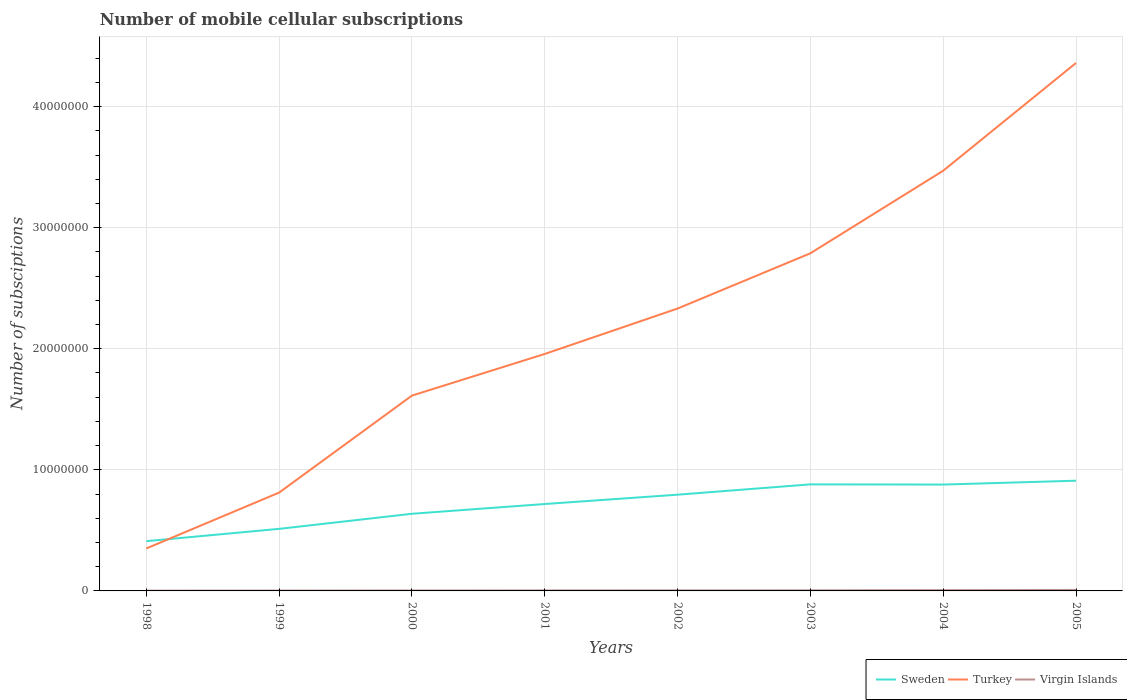Is the number of lines equal to the number of legend labels?
Keep it short and to the point. Yes. Across all years, what is the maximum number of mobile cellular subscriptions in Virgin Islands?
Your response must be concise. 2.50e+04. In which year was the number of mobile cellular subscriptions in Sweden maximum?
Your response must be concise. 1998. What is the total number of mobile cellular subscriptions in Sweden in the graph?
Ensure brevity in your answer.  -1.25e+06. What is the difference between the highest and the second highest number of mobile cellular subscriptions in Sweden?
Ensure brevity in your answer.  5.00e+06. What is the difference between the highest and the lowest number of mobile cellular subscriptions in Sweden?
Offer a very short reply. 4. How many lines are there?
Provide a succinct answer. 3. How many years are there in the graph?
Give a very brief answer. 8. Are the values on the major ticks of Y-axis written in scientific E-notation?
Ensure brevity in your answer.  No. How many legend labels are there?
Make the answer very short. 3. How are the legend labels stacked?
Provide a succinct answer. Horizontal. What is the title of the graph?
Provide a succinct answer. Number of mobile cellular subscriptions. Does "Chile" appear as one of the legend labels in the graph?
Provide a short and direct response. No. What is the label or title of the Y-axis?
Your answer should be very brief. Number of subsciptions. What is the Number of subsciptions of Sweden in 1998?
Make the answer very short. 4.11e+06. What is the Number of subsciptions in Turkey in 1998?
Offer a very short reply. 3.51e+06. What is the Number of subsciptions in Virgin Islands in 1998?
Offer a terse response. 2.50e+04. What is the Number of subsciptions in Sweden in 1999?
Your answer should be very brief. 5.13e+06. What is the Number of subsciptions of Turkey in 1999?
Keep it short and to the point. 8.12e+06. What is the Number of subsciptions in Sweden in 2000?
Your response must be concise. 6.37e+06. What is the Number of subsciptions of Turkey in 2000?
Provide a succinct answer. 1.61e+07. What is the Number of subsciptions of Virgin Islands in 2000?
Keep it short and to the point. 3.50e+04. What is the Number of subsciptions of Sweden in 2001?
Give a very brief answer. 7.18e+06. What is the Number of subsciptions of Turkey in 2001?
Your response must be concise. 1.96e+07. What is the Number of subsciptions of Virgin Islands in 2001?
Provide a succinct answer. 4.10e+04. What is the Number of subsciptions of Sweden in 2002?
Give a very brief answer. 7.95e+06. What is the Number of subsciptions in Turkey in 2002?
Ensure brevity in your answer.  2.33e+07. What is the Number of subsciptions of Virgin Islands in 2002?
Ensure brevity in your answer.  4.52e+04. What is the Number of subsciptions in Sweden in 2003?
Ensure brevity in your answer.  8.80e+06. What is the Number of subsciptions in Turkey in 2003?
Your answer should be very brief. 2.79e+07. What is the Number of subsciptions of Virgin Islands in 2003?
Your answer should be very brief. 4.93e+04. What is the Number of subsciptions of Sweden in 2004?
Offer a very short reply. 8.78e+06. What is the Number of subsciptions of Turkey in 2004?
Your answer should be compact. 3.47e+07. What is the Number of subsciptions in Virgin Islands in 2004?
Your answer should be compact. 6.42e+04. What is the Number of subsciptions in Sweden in 2005?
Make the answer very short. 9.10e+06. What is the Number of subsciptions in Turkey in 2005?
Offer a terse response. 4.36e+07. What is the Number of subsciptions in Virgin Islands in 2005?
Your answer should be very brief. 8.03e+04. Across all years, what is the maximum Number of subsciptions of Sweden?
Make the answer very short. 9.10e+06. Across all years, what is the maximum Number of subsciptions of Turkey?
Your response must be concise. 4.36e+07. Across all years, what is the maximum Number of subsciptions of Virgin Islands?
Offer a very short reply. 8.03e+04. Across all years, what is the minimum Number of subsciptions in Sweden?
Your answer should be very brief. 4.11e+06. Across all years, what is the minimum Number of subsciptions in Turkey?
Your answer should be very brief. 3.51e+06. Across all years, what is the minimum Number of subsciptions in Virgin Islands?
Offer a very short reply. 2.50e+04. What is the total Number of subsciptions of Sweden in the graph?
Offer a terse response. 5.74e+07. What is the total Number of subsciptions of Turkey in the graph?
Ensure brevity in your answer.  1.77e+08. What is the total Number of subsciptions of Virgin Islands in the graph?
Give a very brief answer. 3.70e+05. What is the difference between the Number of subsciptions in Sweden in 1998 and that in 1999?
Your answer should be compact. -1.02e+06. What is the difference between the Number of subsciptions in Turkey in 1998 and that in 1999?
Provide a succinct answer. -4.62e+06. What is the difference between the Number of subsciptions in Virgin Islands in 1998 and that in 1999?
Ensure brevity in your answer.  -5000. What is the difference between the Number of subsciptions in Sweden in 1998 and that in 2000?
Provide a short and direct response. -2.26e+06. What is the difference between the Number of subsciptions of Turkey in 1998 and that in 2000?
Offer a very short reply. -1.26e+07. What is the difference between the Number of subsciptions in Sweden in 1998 and that in 2001?
Offer a terse response. -3.07e+06. What is the difference between the Number of subsciptions of Turkey in 1998 and that in 2001?
Give a very brief answer. -1.61e+07. What is the difference between the Number of subsciptions of Virgin Islands in 1998 and that in 2001?
Ensure brevity in your answer.  -1.60e+04. What is the difference between the Number of subsciptions in Sweden in 1998 and that in 2002?
Your answer should be very brief. -3.84e+06. What is the difference between the Number of subsciptions of Turkey in 1998 and that in 2002?
Offer a very short reply. -1.98e+07. What is the difference between the Number of subsciptions of Virgin Islands in 1998 and that in 2002?
Provide a succinct answer. -2.02e+04. What is the difference between the Number of subsciptions in Sweden in 1998 and that in 2003?
Ensure brevity in your answer.  -4.69e+06. What is the difference between the Number of subsciptions of Turkey in 1998 and that in 2003?
Offer a terse response. -2.44e+07. What is the difference between the Number of subsciptions of Virgin Islands in 1998 and that in 2003?
Make the answer very short. -2.43e+04. What is the difference between the Number of subsciptions of Sweden in 1998 and that in 2004?
Keep it short and to the point. -4.68e+06. What is the difference between the Number of subsciptions of Turkey in 1998 and that in 2004?
Ensure brevity in your answer.  -3.12e+07. What is the difference between the Number of subsciptions of Virgin Islands in 1998 and that in 2004?
Provide a short and direct response. -3.92e+04. What is the difference between the Number of subsciptions in Sweden in 1998 and that in 2005?
Offer a terse response. -5.00e+06. What is the difference between the Number of subsciptions of Turkey in 1998 and that in 2005?
Give a very brief answer. -4.01e+07. What is the difference between the Number of subsciptions in Virgin Islands in 1998 and that in 2005?
Offer a very short reply. -5.53e+04. What is the difference between the Number of subsciptions of Sweden in 1999 and that in 2000?
Provide a short and direct response. -1.25e+06. What is the difference between the Number of subsciptions of Turkey in 1999 and that in 2000?
Keep it short and to the point. -8.01e+06. What is the difference between the Number of subsciptions in Virgin Islands in 1999 and that in 2000?
Provide a succinct answer. -5000. What is the difference between the Number of subsciptions in Sweden in 1999 and that in 2001?
Your answer should be compact. -2.05e+06. What is the difference between the Number of subsciptions of Turkey in 1999 and that in 2001?
Provide a short and direct response. -1.15e+07. What is the difference between the Number of subsciptions in Virgin Islands in 1999 and that in 2001?
Offer a very short reply. -1.10e+04. What is the difference between the Number of subsciptions of Sweden in 1999 and that in 2002?
Your response must be concise. -2.82e+06. What is the difference between the Number of subsciptions of Turkey in 1999 and that in 2002?
Offer a very short reply. -1.52e+07. What is the difference between the Number of subsciptions of Virgin Islands in 1999 and that in 2002?
Offer a very short reply. -1.52e+04. What is the difference between the Number of subsciptions in Sweden in 1999 and that in 2003?
Your answer should be very brief. -3.68e+06. What is the difference between the Number of subsciptions of Turkey in 1999 and that in 2003?
Ensure brevity in your answer.  -1.98e+07. What is the difference between the Number of subsciptions of Virgin Islands in 1999 and that in 2003?
Make the answer very short. -1.93e+04. What is the difference between the Number of subsciptions in Sweden in 1999 and that in 2004?
Ensure brevity in your answer.  -3.66e+06. What is the difference between the Number of subsciptions in Turkey in 1999 and that in 2004?
Ensure brevity in your answer.  -2.66e+07. What is the difference between the Number of subsciptions of Virgin Islands in 1999 and that in 2004?
Your response must be concise. -3.42e+04. What is the difference between the Number of subsciptions of Sweden in 1999 and that in 2005?
Make the answer very short. -3.98e+06. What is the difference between the Number of subsciptions in Turkey in 1999 and that in 2005?
Give a very brief answer. -3.55e+07. What is the difference between the Number of subsciptions in Virgin Islands in 1999 and that in 2005?
Ensure brevity in your answer.  -5.03e+04. What is the difference between the Number of subsciptions in Sweden in 2000 and that in 2001?
Keep it short and to the point. -8.06e+05. What is the difference between the Number of subsciptions of Turkey in 2000 and that in 2001?
Offer a very short reply. -3.44e+06. What is the difference between the Number of subsciptions in Virgin Islands in 2000 and that in 2001?
Offer a terse response. -6000. What is the difference between the Number of subsciptions of Sweden in 2000 and that in 2002?
Provide a short and direct response. -1.58e+06. What is the difference between the Number of subsciptions in Turkey in 2000 and that in 2002?
Give a very brief answer. -7.19e+06. What is the difference between the Number of subsciptions of Virgin Islands in 2000 and that in 2002?
Provide a short and direct response. -1.02e+04. What is the difference between the Number of subsciptions in Sweden in 2000 and that in 2003?
Give a very brief answer. -2.43e+06. What is the difference between the Number of subsciptions of Turkey in 2000 and that in 2003?
Your answer should be very brief. -1.18e+07. What is the difference between the Number of subsciptions in Virgin Islands in 2000 and that in 2003?
Offer a very short reply. -1.43e+04. What is the difference between the Number of subsciptions in Sweden in 2000 and that in 2004?
Give a very brief answer. -2.41e+06. What is the difference between the Number of subsciptions of Turkey in 2000 and that in 2004?
Offer a terse response. -1.86e+07. What is the difference between the Number of subsciptions of Virgin Islands in 2000 and that in 2004?
Offer a very short reply. -2.92e+04. What is the difference between the Number of subsciptions of Sweden in 2000 and that in 2005?
Ensure brevity in your answer.  -2.73e+06. What is the difference between the Number of subsciptions of Turkey in 2000 and that in 2005?
Your answer should be compact. -2.75e+07. What is the difference between the Number of subsciptions of Virgin Islands in 2000 and that in 2005?
Give a very brief answer. -4.53e+04. What is the difference between the Number of subsciptions in Sweden in 2001 and that in 2002?
Make the answer very short. -7.71e+05. What is the difference between the Number of subsciptions in Turkey in 2001 and that in 2002?
Your response must be concise. -3.75e+06. What is the difference between the Number of subsciptions in Virgin Islands in 2001 and that in 2002?
Keep it short and to the point. -4150. What is the difference between the Number of subsciptions in Sweden in 2001 and that in 2003?
Ensure brevity in your answer.  -1.62e+06. What is the difference between the Number of subsciptions in Turkey in 2001 and that in 2003?
Make the answer very short. -8.31e+06. What is the difference between the Number of subsciptions in Virgin Islands in 2001 and that in 2003?
Provide a succinct answer. -8300. What is the difference between the Number of subsciptions of Sweden in 2001 and that in 2004?
Provide a short and direct response. -1.61e+06. What is the difference between the Number of subsciptions in Turkey in 2001 and that in 2004?
Your response must be concise. -1.51e+07. What is the difference between the Number of subsciptions in Virgin Islands in 2001 and that in 2004?
Make the answer very short. -2.32e+04. What is the difference between the Number of subsciptions in Sweden in 2001 and that in 2005?
Make the answer very short. -1.93e+06. What is the difference between the Number of subsciptions in Turkey in 2001 and that in 2005?
Provide a short and direct response. -2.40e+07. What is the difference between the Number of subsciptions of Virgin Islands in 2001 and that in 2005?
Keep it short and to the point. -3.93e+04. What is the difference between the Number of subsciptions of Sweden in 2002 and that in 2003?
Offer a terse response. -8.52e+05. What is the difference between the Number of subsciptions in Turkey in 2002 and that in 2003?
Provide a short and direct response. -4.56e+06. What is the difference between the Number of subsciptions of Virgin Islands in 2002 and that in 2003?
Provide a succinct answer. -4150. What is the difference between the Number of subsciptions in Sweden in 2002 and that in 2004?
Your answer should be very brief. -8.36e+05. What is the difference between the Number of subsciptions in Turkey in 2002 and that in 2004?
Your answer should be compact. -1.14e+07. What is the difference between the Number of subsciptions of Virgin Islands in 2002 and that in 2004?
Provide a short and direct response. -1.90e+04. What is the difference between the Number of subsciptions in Sweden in 2002 and that in 2005?
Your answer should be very brief. -1.16e+06. What is the difference between the Number of subsciptions in Turkey in 2002 and that in 2005?
Offer a very short reply. -2.03e+07. What is the difference between the Number of subsciptions of Virgin Islands in 2002 and that in 2005?
Keep it short and to the point. -3.52e+04. What is the difference between the Number of subsciptions of Sweden in 2003 and that in 2004?
Provide a succinct answer. 1.60e+04. What is the difference between the Number of subsciptions of Turkey in 2003 and that in 2004?
Offer a terse response. -6.82e+06. What is the difference between the Number of subsciptions of Virgin Islands in 2003 and that in 2004?
Ensure brevity in your answer.  -1.49e+04. What is the difference between the Number of subsciptions of Sweden in 2003 and that in 2005?
Provide a succinct answer. -3.03e+05. What is the difference between the Number of subsciptions of Turkey in 2003 and that in 2005?
Provide a succinct answer. -1.57e+07. What is the difference between the Number of subsciptions of Virgin Islands in 2003 and that in 2005?
Provide a short and direct response. -3.10e+04. What is the difference between the Number of subsciptions in Sweden in 2004 and that in 2005?
Your answer should be very brief. -3.19e+05. What is the difference between the Number of subsciptions in Turkey in 2004 and that in 2005?
Your answer should be compact. -8.90e+06. What is the difference between the Number of subsciptions in Virgin Islands in 2004 and that in 2005?
Provide a succinct answer. -1.61e+04. What is the difference between the Number of subsciptions in Sweden in 1998 and the Number of subsciptions in Turkey in 1999?
Offer a very short reply. -4.01e+06. What is the difference between the Number of subsciptions in Sweden in 1998 and the Number of subsciptions in Virgin Islands in 1999?
Ensure brevity in your answer.  4.08e+06. What is the difference between the Number of subsciptions of Turkey in 1998 and the Number of subsciptions of Virgin Islands in 1999?
Give a very brief answer. 3.48e+06. What is the difference between the Number of subsciptions of Sweden in 1998 and the Number of subsciptions of Turkey in 2000?
Provide a succinct answer. -1.20e+07. What is the difference between the Number of subsciptions in Sweden in 1998 and the Number of subsciptions in Virgin Islands in 2000?
Your response must be concise. 4.07e+06. What is the difference between the Number of subsciptions of Turkey in 1998 and the Number of subsciptions of Virgin Islands in 2000?
Provide a succinct answer. 3.47e+06. What is the difference between the Number of subsciptions of Sweden in 1998 and the Number of subsciptions of Turkey in 2001?
Give a very brief answer. -1.55e+07. What is the difference between the Number of subsciptions in Sweden in 1998 and the Number of subsciptions in Virgin Islands in 2001?
Your answer should be very brief. 4.07e+06. What is the difference between the Number of subsciptions in Turkey in 1998 and the Number of subsciptions in Virgin Islands in 2001?
Give a very brief answer. 3.47e+06. What is the difference between the Number of subsciptions of Sweden in 1998 and the Number of subsciptions of Turkey in 2002?
Offer a terse response. -1.92e+07. What is the difference between the Number of subsciptions in Sweden in 1998 and the Number of subsciptions in Virgin Islands in 2002?
Make the answer very short. 4.06e+06. What is the difference between the Number of subsciptions in Turkey in 1998 and the Number of subsciptions in Virgin Islands in 2002?
Provide a short and direct response. 3.46e+06. What is the difference between the Number of subsciptions of Sweden in 1998 and the Number of subsciptions of Turkey in 2003?
Give a very brief answer. -2.38e+07. What is the difference between the Number of subsciptions in Sweden in 1998 and the Number of subsciptions in Virgin Islands in 2003?
Offer a terse response. 4.06e+06. What is the difference between the Number of subsciptions in Turkey in 1998 and the Number of subsciptions in Virgin Islands in 2003?
Your answer should be compact. 3.46e+06. What is the difference between the Number of subsciptions of Sweden in 1998 and the Number of subsciptions of Turkey in 2004?
Make the answer very short. -3.06e+07. What is the difference between the Number of subsciptions in Sweden in 1998 and the Number of subsciptions in Virgin Islands in 2004?
Give a very brief answer. 4.04e+06. What is the difference between the Number of subsciptions in Turkey in 1998 and the Number of subsciptions in Virgin Islands in 2004?
Offer a terse response. 3.44e+06. What is the difference between the Number of subsciptions in Sweden in 1998 and the Number of subsciptions in Turkey in 2005?
Offer a terse response. -3.95e+07. What is the difference between the Number of subsciptions in Sweden in 1998 and the Number of subsciptions in Virgin Islands in 2005?
Keep it short and to the point. 4.03e+06. What is the difference between the Number of subsciptions in Turkey in 1998 and the Number of subsciptions in Virgin Islands in 2005?
Make the answer very short. 3.43e+06. What is the difference between the Number of subsciptions in Sweden in 1999 and the Number of subsciptions in Turkey in 2000?
Ensure brevity in your answer.  -1.10e+07. What is the difference between the Number of subsciptions in Sweden in 1999 and the Number of subsciptions in Virgin Islands in 2000?
Keep it short and to the point. 5.09e+06. What is the difference between the Number of subsciptions in Turkey in 1999 and the Number of subsciptions in Virgin Islands in 2000?
Offer a very short reply. 8.09e+06. What is the difference between the Number of subsciptions of Sweden in 1999 and the Number of subsciptions of Turkey in 2001?
Your answer should be compact. -1.44e+07. What is the difference between the Number of subsciptions of Sweden in 1999 and the Number of subsciptions of Virgin Islands in 2001?
Keep it short and to the point. 5.08e+06. What is the difference between the Number of subsciptions in Turkey in 1999 and the Number of subsciptions in Virgin Islands in 2001?
Your response must be concise. 8.08e+06. What is the difference between the Number of subsciptions of Sweden in 1999 and the Number of subsciptions of Turkey in 2002?
Offer a terse response. -1.82e+07. What is the difference between the Number of subsciptions in Sweden in 1999 and the Number of subsciptions in Virgin Islands in 2002?
Provide a succinct answer. 5.08e+06. What is the difference between the Number of subsciptions in Turkey in 1999 and the Number of subsciptions in Virgin Islands in 2002?
Offer a terse response. 8.08e+06. What is the difference between the Number of subsciptions of Sweden in 1999 and the Number of subsciptions of Turkey in 2003?
Offer a terse response. -2.28e+07. What is the difference between the Number of subsciptions of Sweden in 1999 and the Number of subsciptions of Virgin Islands in 2003?
Provide a short and direct response. 5.08e+06. What is the difference between the Number of subsciptions in Turkey in 1999 and the Number of subsciptions in Virgin Islands in 2003?
Keep it short and to the point. 8.07e+06. What is the difference between the Number of subsciptions in Sweden in 1999 and the Number of subsciptions in Turkey in 2004?
Ensure brevity in your answer.  -2.96e+07. What is the difference between the Number of subsciptions in Sweden in 1999 and the Number of subsciptions in Virgin Islands in 2004?
Provide a short and direct response. 5.06e+06. What is the difference between the Number of subsciptions in Turkey in 1999 and the Number of subsciptions in Virgin Islands in 2004?
Provide a short and direct response. 8.06e+06. What is the difference between the Number of subsciptions in Sweden in 1999 and the Number of subsciptions in Turkey in 2005?
Your answer should be very brief. -3.85e+07. What is the difference between the Number of subsciptions in Sweden in 1999 and the Number of subsciptions in Virgin Islands in 2005?
Your answer should be very brief. 5.05e+06. What is the difference between the Number of subsciptions of Turkey in 1999 and the Number of subsciptions of Virgin Islands in 2005?
Ensure brevity in your answer.  8.04e+06. What is the difference between the Number of subsciptions of Sweden in 2000 and the Number of subsciptions of Turkey in 2001?
Give a very brief answer. -1.32e+07. What is the difference between the Number of subsciptions in Sweden in 2000 and the Number of subsciptions in Virgin Islands in 2001?
Ensure brevity in your answer.  6.33e+06. What is the difference between the Number of subsciptions of Turkey in 2000 and the Number of subsciptions of Virgin Islands in 2001?
Your response must be concise. 1.61e+07. What is the difference between the Number of subsciptions in Sweden in 2000 and the Number of subsciptions in Turkey in 2002?
Ensure brevity in your answer.  -1.70e+07. What is the difference between the Number of subsciptions of Sweden in 2000 and the Number of subsciptions of Virgin Islands in 2002?
Your response must be concise. 6.33e+06. What is the difference between the Number of subsciptions in Turkey in 2000 and the Number of subsciptions in Virgin Islands in 2002?
Provide a succinct answer. 1.61e+07. What is the difference between the Number of subsciptions in Sweden in 2000 and the Number of subsciptions in Turkey in 2003?
Offer a very short reply. -2.15e+07. What is the difference between the Number of subsciptions of Sweden in 2000 and the Number of subsciptions of Virgin Islands in 2003?
Provide a short and direct response. 6.32e+06. What is the difference between the Number of subsciptions of Turkey in 2000 and the Number of subsciptions of Virgin Islands in 2003?
Your answer should be very brief. 1.61e+07. What is the difference between the Number of subsciptions of Sweden in 2000 and the Number of subsciptions of Turkey in 2004?
Your answer should be compact. -2.83e+07. What is the difference between the Number of subsciptions of Sweden in 2000 and the Number of subsciptions of Virgin Islands in 2004?
Offer a very short reply. 6.31e+06. What is the difference between the Number of subsciptions in Turkey in 2000 and the Number of subsciptions in Virgin Islands in 2004?
Your answer should be compact. 1.61e+07. What is the difference between the Number of subsciptions in Sweden in 2000 and the Number of subsciptions in Turkey in 2005?
Your response must be concise. -3.72e+07. What is the difference between the Number of subsciptions of Sweden in 2000 and the Number of subsciptions of Virgin Islands in 2005?
Keep it short and to the point. 6.29e+06. What is the difference between the Number of subsciptions in Turkey in 2000 and the Number of subsciptions in Virgin Islands in 2005?
Offer a terse response. 1.61e+07. What is the difference between the Number of subsciptions of Sweden in 2001 and the Number of subsciptions of Turkey in 2002?
Keep it short and to the point. -1.61e+07. What is the difference between the Number of subsciptions in Sweden in 2001 and the Number of subsciptions in Virgin Islands in 2002?
Provide a succinct answer. 7.13e+06. What is the difference between the Number of subsciptions of Turkey in 2001 and the Number of subsciptions of Virgin Islands in 2002?
Ensure brevity in your answer.  1.95e+07. What is the difference between the Number of subsciptions of Sweden in 2001 and the Number of subsciptions of Turkey in 2003?
Give a very brief answer. -2.07e+07. What is the difference between the Number of subsciptions in Sweden in 2001 and the Number of subsciptions in Virgin Islands in 2003?
Keep it short and to the point. 7.13e+06. What is the difference between the Number of subsciptions of Turkey in 2001 and the Number of subsciptions of Virgin Islands in 2003?
Your answer should be very brief. 1.95e+07. What is the difference between the Number of subsciptions in Sweden in 2001 and the Number of subsciptions in Turkey in 2004?
Offer a very short reply. -2.75e+07. What is the difference between the Number of subsciptions of Sweden in 2001 and the Number of subsciptions of Virgin Islands in 2004?
Make the answer very short. 7.11e+06. What is the difference between the Number of subsciptions of Turkey in 2001 and the Number of subsciptions of Virgin Islands in 2004?
Keep it short and to the point. 1.95e+07. What is the difference between the Number of subsciptions in Sweden in 2001 and the Number of subsciptions in Turkey in 2005?
Your response must be concise. -3.64e+07. What is the difference between the Number of subsciptions in Sweden in 2001 and the Number of subsciptions in Virgin Islands in 2005?
Provide a succinct answer. 7.10e+06. What is the difference between the Number of subsciptions of Turkey in 2001 and the Number of subsciptions of Virgin Islands in 2005?
Make the answer very short. 1.95e+07. What is the difference between the Number of subsciptions of Sweden in 2002 and the Number of subsciptions of Turkey in 2003?
Offer a terse response. -1.99e+07. What is the difference between the Number of subsciptions in Sweden in 2002 and the Number of subsciptions in Virgin Islands in 2003?
Provide a succinct answer. 7.90e+06. What is the difference between the Number of subsciptions in Turkey in 2002 and the Number of subsciptions in Virgin Islands in 2003?
Your response must be concise. 2.33e+07. What is the difference between the Number of subsciptions in Sweden in 2002 and the Number of subsciptions in Turkey in 2004?
Provide a short and direct response. -2.68e+07. What is the difference between the Number of subsciptions in Sweden in 2002 and the Number of subsciptions in Virgin Islands in 2004?
Your response must be concise. 7.88e+06. What is the difference between the Number of subsciptions of Turkey in 2002 and the Number of subsciptions of Virgin Islands in 2004?
Offer a very short reply. 2.33e+07. What is the difference between the Number of subsciptions of Sweden in 2002 and the Number of subsciptions of Turkey in 2005?
Make the answer very short. -3.57e+07. What is the difference between the Number of subsciptions in Sweden in 2002 and the Number of subsciptions in Virgin Islands in 2005?
Offer a terse response. 7.87e+06. What is the difference between the Number of subsciptions in Turkey in 2002 and the Number of subsciptions in Virgin Islands in 2005?
Provide a succinct answer. 2.32e+07. What is the difference between the Number of subsciptions of Sweden in 2003 and the Number of subsciptions of Turkey in 2004?
Offer a terse response. -2.59e+07. What is the difference between the Number of subsciptions of Sweden in 2003 and the Number of subsciptions of Virgin Islands in 2004?
Keep it short and to the point. 8.74e+06. What is the difference between the Number of subsciptions in Turkey in 2003 and the Number of subsciptions in Virgin Islands in 2004?
Your answer should be compact. 2.78e+07. What is the difference between the Number of subsciptions in Sweden in 2003 and the Number of subsciptions in Turkey in 2005?
Keep it short and to the point. -3.48e+07. What is the difference between the Number of subsciptions in Sweden in 2003 and the Number of subsciptions in Virgin Islands in 2005?
Ensure brevity in your answer.  8.72e+06. What is the difference between the Number of subsciptions of Turkey in 2003 and the Number of subsciptions of Virgin Islands in 2005?
Give a very brief answer. 2.78e+07. What is the difference between the Number of subsciptions of Sweden in 2004 and the Number of subsciptions of Turkey in 2005?
Offer a terse response. -3.48e+07. What is the difference between the Number of subsciptions of Sweden in 2004 and the Number of subsciptions of Virgin Islands in 2005?
Your answer should be very brief. 8.70e+06. What is the difference between the Number of subsciptions of Turkey in 2004 and the Number of subsciptions of Virgin Islands in 2005?
Give a very brief answer. 3.46e+07. What is the average Number of subsciptions of Sweden per year?
Keep it short and to the point. 7.18e+06. What is the average Number of subsciptions of Turkey per year?
Offer a terse response. 2.21e+07. What is the average Number of subsciptions of Virgin Islands per year?
Your answer should be compact. 4.62e+04. In the year 1998, what is the difference between the Number of subsciptions of Sweden and Number of subsciptions of Turkey?
Your answer should be very brief. 6.03e+05. In the year 1998, what is the difference between the Number of subsciptions in Sweden and Number of subsciptions in Virgin Islands?
Your response must be concise. 4.08e+06. In the year 1998, what is the difference between the Number of subsciptions in Turkey and Number of subsciptions in Virgin Islands?
Offer a very short reply. 3.48e+06. In the year 1999, what is the difference between the Number of subsciptions in Sweden and Number of subsciptions in Turkey?
Provide a succinct answer. -3.00e+06. In the year 1999, what is the difference between the Number of subsciptions of Sweden and Number of subsciptions of Virgin Islands?
Ensure brevity in your answer.  5.10e+06. In the year 1999, what is the difference between the Number of subsciptions of Turkey and Number of subsciptions of Virgin Islands?
Make the answer very short. 8.09e+06. In the year 2000, what is the difference between the Number of subsciptions in Sweden and Number of subsciptions in Turkey?
Offer a very short reply. -9.76e+06. In the year 2000, what is the difference between the Number of subsciptions in Sweden and Number of subsciptions in Virgin Islands?
Offer a very short reply. 6.34e+06. In the year 2000, what is the difference between the Number of subsciptions in Turkey and Number of subsciptions in Virgin Islands?
Give a very brief answer. 1.61e+07. In the year 2001, what is the difference between the Number of subsciptions in Sweden and Number of subsciptions in Turkey?
Provide a succinct answer. -1.24e+07. In the year 2001, what is the difference between the Number of subsciptions in Sweden and Number of subsciptions in Virgin Islands?
Keep it short and to the point. 7.14e+06. In the year 2001, what is the difference between the Number of subsciptions in Turkey and Number of subsciptions in Virgin Islands?
Offer a very short reply. 1.95e+07. In the year 2002, what is the difference between the Number of subsciptions of Sweden and Number of subsciptions of Turkey?
Your answer should be compact. -1.54e+07. In the year 2002, what is the difference between the Number of subsciptions of Sweden and Number of subsciptions of Virgin Islands?
Offer a very short reply. 7.90e+06. In the year 2002, what is the difference between the Number of subsciptions of Turkey and Number of subsciptions of Virgin Islands?
Offer a terse response. 2.33e+07. In the year 2003, what is the difference between the Number of subsciptions in Sweden and Number of subsciptions in Turkey?
Your response must be concise. -1.91e+07. In the year 2003, what is the difference between the Number of subsciptions of Sweden and Number of subsciptions of Virgin Islands?
Offer a terse response. 8.75e+06. In the year 2003, what is the difference between the Number of subsciptions in Turkey and Number of subsciptions in Virgin Islands?
Your answer should be very brief. 2.78e+07. In the year 2004, what is the difference between the Number of subsciptions in Sweden and Number of subsciptions in Turkey?
Ensure brevity in your answer.  -2.59e+07. In the year 2004, what is the difference between the Number of subsciptions of Sweden and Number of subsciptions of Virgin Islands?
Your answer should be compact. 8.72e+06. In the year 2004, what is the difference between the Number of subsciptions of Turkey and Number of subsciptions of Virgin Islands?
Keep it short and to the point. 3.46e+07. In the year 2005, what is the difference between the Number of subsciptions of Sweden and Number of subsciptions of Turkey?
Ensure brevity in your answer.  -3.45e+07. In the year 2005, what is the difference between the Number of subsciptions in Sweden and Number of subsciptions in Virgin Islands?
Keep it short and to the point. 9.02e+06. In the year 2005, what is the difference between the Number of subsciptions of Turkey and Number of subsciptions of Virgin Islands?
Your answer should be compact. 4.35e+07. What is the ratio of the Number of subsciptions in Sweden in 1998 to that in 1999?
Offer a very short reply. 0.8. What is the ratio of the Number of subsciptions of Turkey in 1998 to that in 1999?
Keep it short and to the point. 0.43. What is the ratio of the Number of subsciptions in Virgin Islands in 1998 to that in 1999?
Keep it short and to the point. 0.83. What is the ratio of the Number of subsciptions of Sweden in 1998 to that in 2000?
Make the answer very short. 0.64. What is the ratio of the Number of subsciptions in Turkey in 1998 to that in 2000?
Give a very brief answer. 0.22. What is the ratio of the Number of subsciptions of Virgin Islands in 1998 to that in 2000?
Ensure brevity in your answer.  0.71. What is the ratio of the Number of subsciptions in Sweden in 1998 to that in 2001?
Keep it short and to the point. 0.57. What is the ratio of the Number of subsciptions in Turkey in 1998 to that in 2001?
Ensure brevity in your answer.  0.18. What is the ratio of the Number of subsciptions of Virgin Islands in 1998 to that in 2001?
Ensure brevity in your answer.  0.61. What is the ratio of the Number of subsciptions in Sweden in 1998 to that in 2002?
Keep it short and to the point. 0.52. What is the ratio of the Number of subsciptions in Turkey in 1998 to that in 2002?
Provide a succinct answer. 0.15. What is the ratio of the Number of subsciptions of Virgin Islands in 1998 to that in 2002?
Provide a succinct answer. 0.55. What is the ratio of the Number of subsciptions of Sweden in 1998 to that in 2003?
Make the answer very short. 0.47. What is the ratio of the Number of subsciptions of Turkey in 1998 to that in 2003?
Your answer should be very brief. 0.13. What is the ratio of the Number of subsciptions of Virgin Islands in 1998 to that in 2003?
Your answer should be very brief. 0.51. What is the ratio of the Number of subsciptions of Sweden in 1998 to that in 2004?
Offer a terse response. 0.47. What is the ratio of the Number of subsciptions in Turkey in 1998 to that in 2004?
Make the answer very short. 0.1. What is the ratio of the Number of subsciptions of Virgin Islands in 1998 to that in 2004?
Your response must be concise. 0.39. What is the ratio of the Number of subsciptions in Sweden in 1998 to that in 2005?
Your answer should be compact. 0.45. What is the ratio of the Number of subsciptions of Turkey in 1998 to that in 2005?
Your answer should be very brief. 0.08. What is the ratio of the Number of subsciptions of Virgin Islands in 1998 to that in 2005?
Your answer should be compact. 0.31. What is the ratio of the Number of subsciptions in Sweden in 1999 to that in 2000?
Give a very brief answer. 0.8. What is the ratio of the Number of subsciptions of Turkey in 1999 to that in 2000?
Ensure brevity in your answer.  0.5. What is the ratio of the Number of subsciptions of Sweden in 1999 to that in 2001?
Make the answer very short. 0.71. What is the ratio of the Number of subsciptions in Turkey in 1999 to that in 2001?
Your response must be concise. 0.41. What is the ratio of the Number of subsciptions in Virgin Islands in 1999 to that in 2001?
Provide a short and direct response. 0.73. What is the ratio of the Number of subsciptions of Sweden in 1999 to that in 2002?
Provide a short and direct response. 0.64. What is the ratio of the Number of subsciptions of Turkey in 1999 to that in 2002?
Make the answer very short. 0.35. What is the ratio of the Number of subsciptions in Virgin Islands in 1999 to that in 2002?
Give a very brief answer. 0.66. What is the ratio of the Number of subsciptions of Sweden in 1999 to that in 2003?
Keep it short and to the point. 0.58. What is the ratio of the Number of subsciptions of Turkey in 1999 to that in 2003?
Your response must be concise. 0.29. What is the ratio of the Number of subsciptions of Virgin Islands in 1999 to that in 2003?
Offer a terse response. 0.61. What is the ratio of the Number of subsciptions in Sweden in 1999 to that in 2004?
Your response must be concise. 0.58. What is the ratio of the Number of subsciptions in Turkey in 1999 to that in 2004?
Your response must be concise. 0.23. What is the ratio of the Number of subsciptions in Virgin Islands in 1999 to that in 2004?
Offer a very short reply. 0.47. What is the ratio of the Number of subsciptions in Sweden in 1999 to that in 2005?
Ensure brevity in your answer.  0.56. What is the ratio of the Number of subsciptions in Turkey in 1999 to that in 2005?
Your answer should be compact. 0.19. What is the ratio of the Number of subsciptions in Virgin Islands in 1999 to that in 2005?
Offer a very short reply. 0.37. What is the ratio of the Number of subsciptions of Sweden in 2000 to that in 2001?
Ensure brevity in your answer.  0.89. What is the ratio of the Number of subsciptions of Turkey in 2000 to that in 2001?
Your answer should be very brief. 0.82. What is the ratio of the Number of subsciptions of Virgin Islands in 2000 to that in 2001?
Keep it short and to the point. 0.85. What is the ratio of the Number of subsciptions of Sweden in 2000 to that in 2002?
Provide a short and direct response. 0.8. What is the ratio of the Number of subsciptions in Turkey in 2000 to that in 2002?
Provide a short and direct response. 0.69. What is the ratio of the Number of subsciptions in Virgin Islands in 2000 to that in 2002?
Keep it short and to the point. 0.78. What is the ratio of the Number of subsciptions of Sweden in 2000 to that in 2003?
Make the answer very short. 0.72. What is the ratio of the Number of subsciptions of Turkey in 2000 to that in 2003?
Give a very brief answer. 0.58. What is the ratio of the Number of subsciptions of Virgin Islands in 2000 to that in 2003?
Your response must be concise. 0.71. What is the ratio of the Number of subsciptions of Sweden in 2000 to that in 2004?
Offer a terse response. 0.73. What is the ratio of the Number of subsciptions in Turkey in 2000 to that in 2004?
Offer a terse response. 0.46. What is the ratio of the Number of subsciptions of Virgin Islands in 2000 to that in 2004?
Give a very brief answer. 0.55. What is the ratio of the Number of subsciptions in Sweden in 2000 to that in 2005?
Your answer should be very brief. 0.7. What is the ratio of the Number of subsciptions in Turkey in 2000 to that in 2005?
Your answer should be very brief. 0.37. What is the ratio of the Number of subsciptions of Virgin Islands in 2000 to that in 2005?
Keep it short and to the point. 0.44. What is the ratio of the Number of subsciptions of Sweden in 2001 to that in 2002?
Provide a short and direct response. 0.9. What is the ratio of the Number of subsciptions in Turkey in 2001 to that in 2002?
Provide a succinct answer. 0.84. What is the ratio of the Number of subsciptions of Virgin Islands in 2001 to that in 2002?
Make the answer very short. 0.91. What is the ratio of the Number of subsciptions of Sweden in 2001 to that in 2003?
Your response must be concise. 0.82. What is the ratio of the Number of subsciptions of Turkey in 2001 to that in 2003?
Give a very brief answer. 0.7. What is the ratio of the Number of subsciptions in Virgin Islands in 2001 to that in 2003?
Keep it short and to the point. 0.83. What is the ratio of the Number of subsciptions in Sweden in 2001 to that in 2004?
Make the answer very short. 0.82. What is the ratio of the Number of subsciptions in Turkey in 2001 to that in 2004?
Make the answer very short. 0.56. What is the ratio of the Number of subsciptions in Virgin Islands in 2001 to that in 2004?
Your response must be concise. 0.64. What is the ratio of the Number of subsciptions of Sweden in 2001 to that in 2005?
Offer a very short reply. 0.79. What is the ratio of the Number of subsciptions of Turkey in 2001 to that in 2005?
Your answer should be compact. 0.45. What is the ratio of the Number of subsciptions of Virgin Islands in 2001 to that in 2005?
Provide a short and direct response. 0.51. What is the ratio of the Number of subsciptions in Sweden in 2002 to that in 2003?
Make the answer very short. 0.9. What is the ratio of the Number of subsciptions of Turkey in 2002 to that in 2003?
Your answer should be compact. 0.84. What is the ratio of the Number of subsciptions in Virgin Islands in 2002 to that in 2003?
Offer a very short reply. 0.92. What is the ratio of the Number of subsciptions in Sweden in 2002 to that in 2004?
Ensure brevity in your answer.  0.9. What is the ratio of the Number of subsciptions in Turkey in 2002 to that in 2004?
Your answer should be compact. 0.67. What is the ratio of the Number of subsciptions of Virgin Islands in 2002 to that in 2004?
Provide a succinct answer. 0.7. What is the ratio of the Number of subsciptions of Sweden in 2002 to that in 2005?
Your answer should be compact. 0.87. What is the ratio of the Number of subsciptions of Turkey in 2002 to that in 2005?
Give a very brief answer. 0.53. What is the ratio of the Number of subsciptions in Virgin Islands in 2002 to that in 2005?
Your answer should be very brief. 0.56. What is the ratio of the Number of subsciptions of Turkey in 2003 to that in 2004?
Your answer should be compact. 0.8. What is the ratio of the Number of subsciptions in Virgin Islands in 2003 to that in 2004?
Keep it short and to the point. 0.77. What is the ratio of the Number of subsciptions of Sweden in 2003 to that in 2005?
Keep it short and to the point. 0.97. What is the ratio of the Number of subsciptions in Turkey in 2003 to that in 2005?
Your answer should be compact. 0.64. What is the ratio of the Number of subsciptions of Virgin Islands in 2003 to that in 2005?
Provide a short and direct response. 0.61. What is the ratio of the Number of subsciptions in Sweden in 2004 to that in 2005?
Ensure brevity in your answer.  0.96. What is the ratio of the Number of subsciptions of Turkey in 2004 to that in 2005?
Make the answer very short. 0.8. What is the ratio of the Number of subsciptions of Virgin Islands in 2004 to that in 2005?
Give a very brief answer. 0.8. What is the difference between the highest and the second highest Number of subsciptions of Sweden?
Ensure brevity in your answer.  3.03e+05. What is the difference between the highest and the second highest Number of subsciptions of Turkey?
Provide a short and direct response. 8.90e+06. What is the difference between the highest and the second highest Number of subsciptions in Virgin Islands?
Provide a succinct answer. 1.61e+04. What is the difference between the highest and the lowest Number of subsciptions of Sweden?
Your answer should be very brief. 5.00e+06. What is the difference between the highest and the lowest Number of subsciptions in Turkey?
Offer a very short reply. 4.01e+07. What is the difference between the highest and the lowest Number of subsciptions of Virgin Islands?
Ensure brevity in your answer.  5.53e+04. 